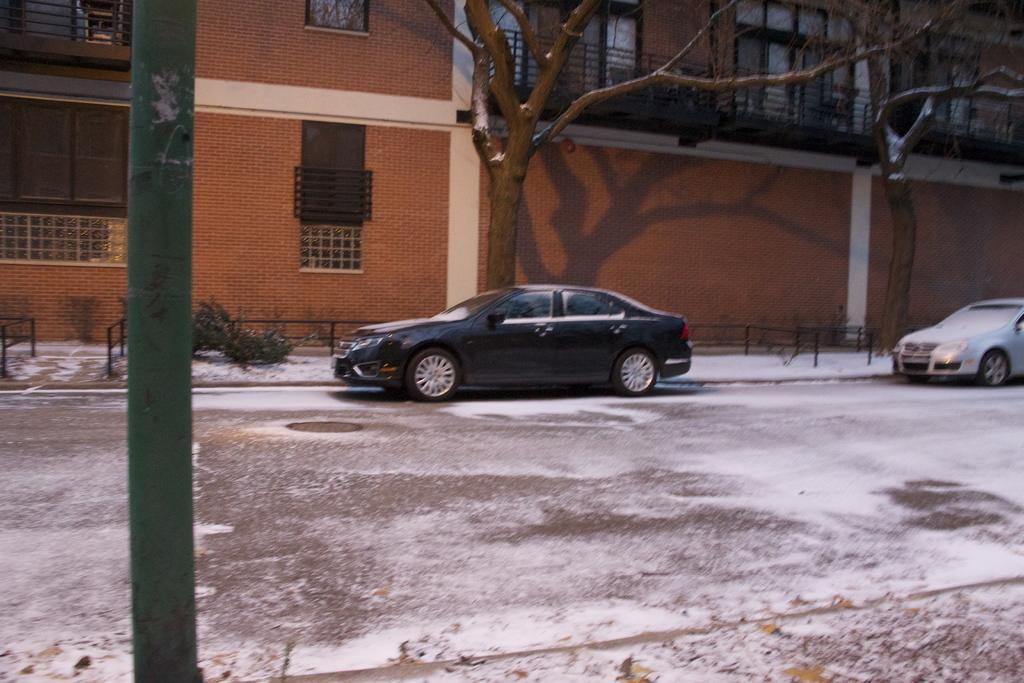What can be seen on the road in the image? There are cars on the road in the image. What object is present in the image that is not a car or a building? There is a pole in the image. What type of vegetation is visible in the image? There are trees in the image. What type of structure can be seen in the background of the image? There is a building with windows in the background of the image. What type of furniture is visible in the image? There is no furniture present in the image. What is the color of the wrist of the person in the image? There is no person present in the image, so it is not possible to determine the color of their wrist. 